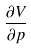<formula> <loc_0><loc_0><loc_500><loc_500>\frac { \partial V } { \partial p }</formula> 